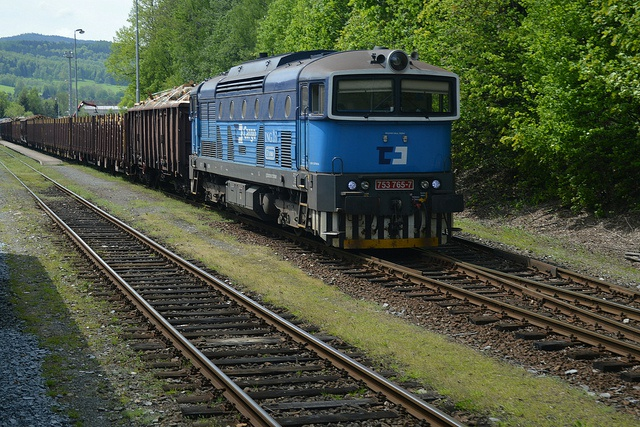Describe the objects in this image and their specific colors. I can see a train in white, black, gray, darkblue, and darkgray tones in this image. 